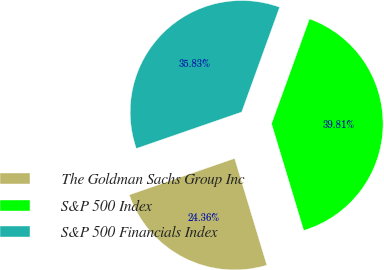Convert chart. <chart><loc_0><loc_0><loc_500><loc_500><pie_chart><fcel>The Goldman Sachs Group Inc<fcel>S&P 500 Index<fcel>S&P 500 Financials Index<nl><fcel>24.36%<fcel>39.81%<fcel>35.83%<nl></chart> 